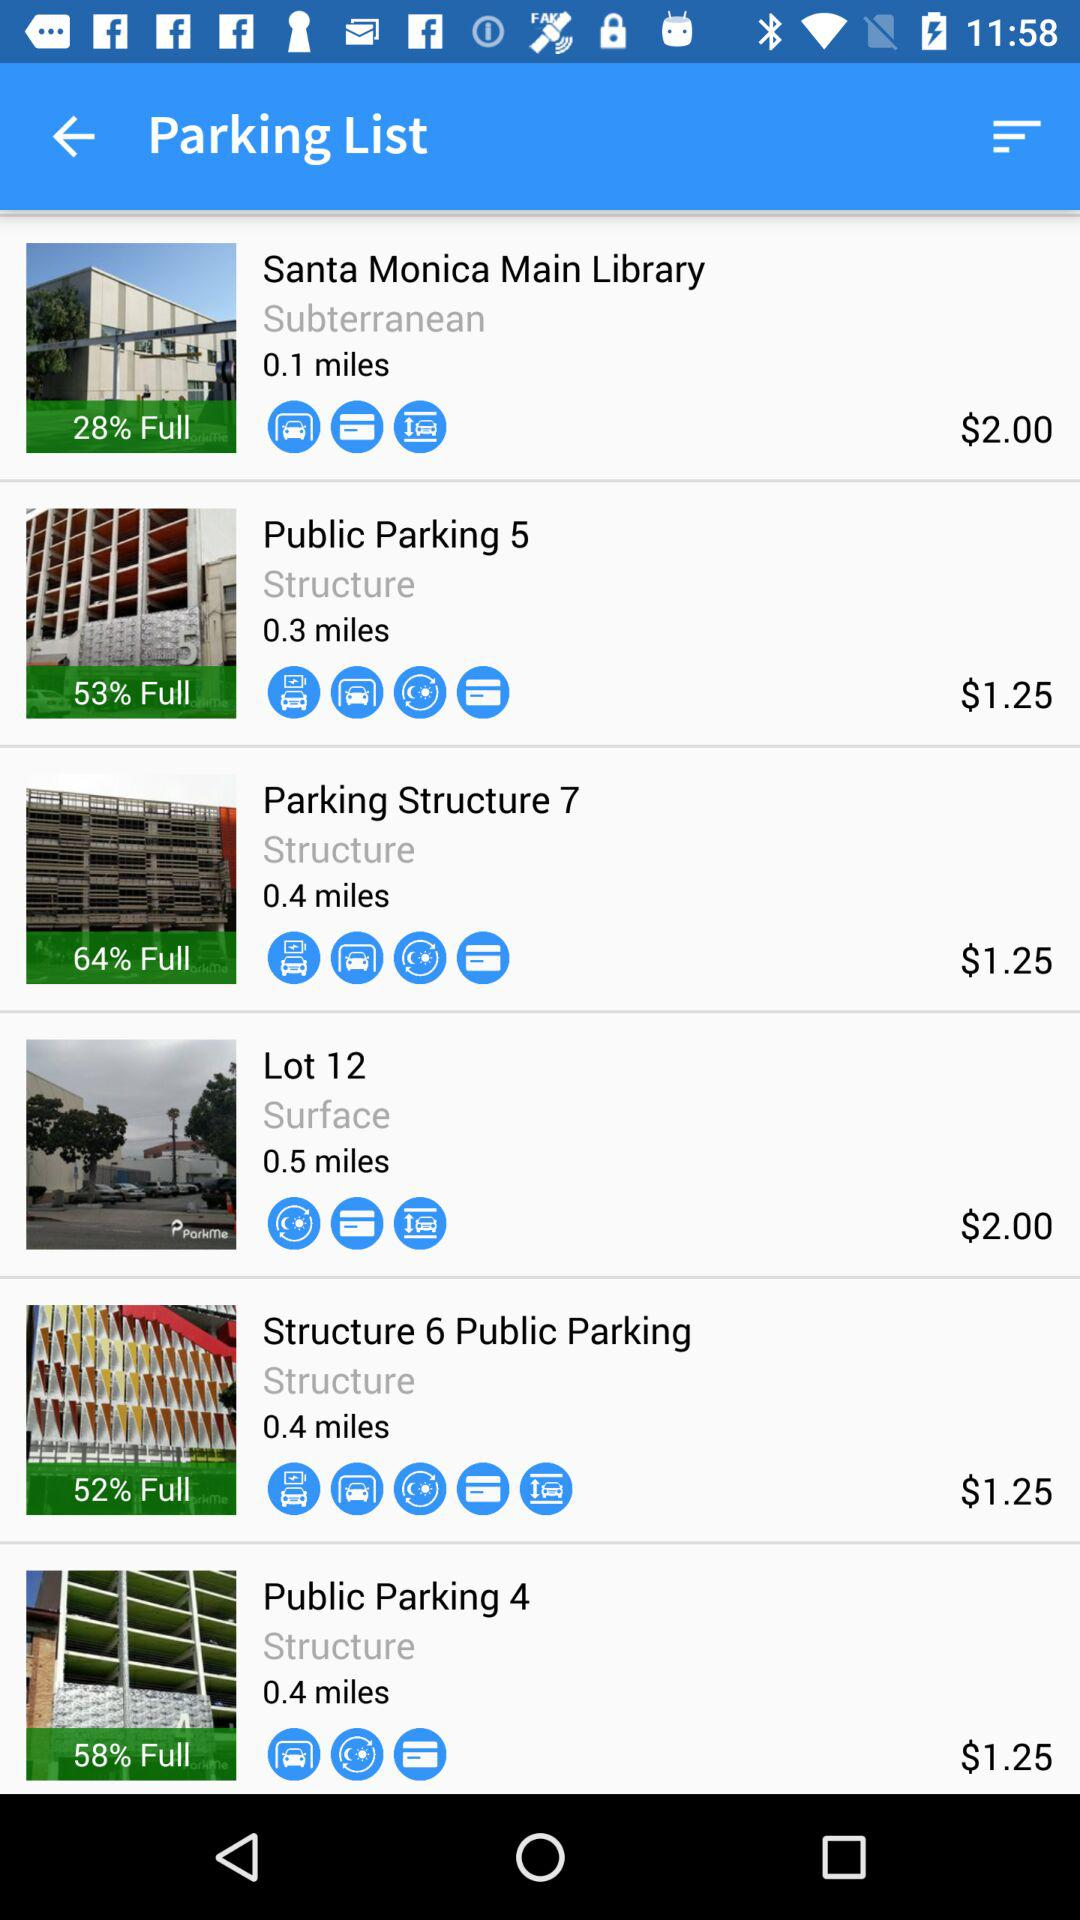How many structures are there with a price of $1.25?
Answer the question using a single word or phrase. 4 